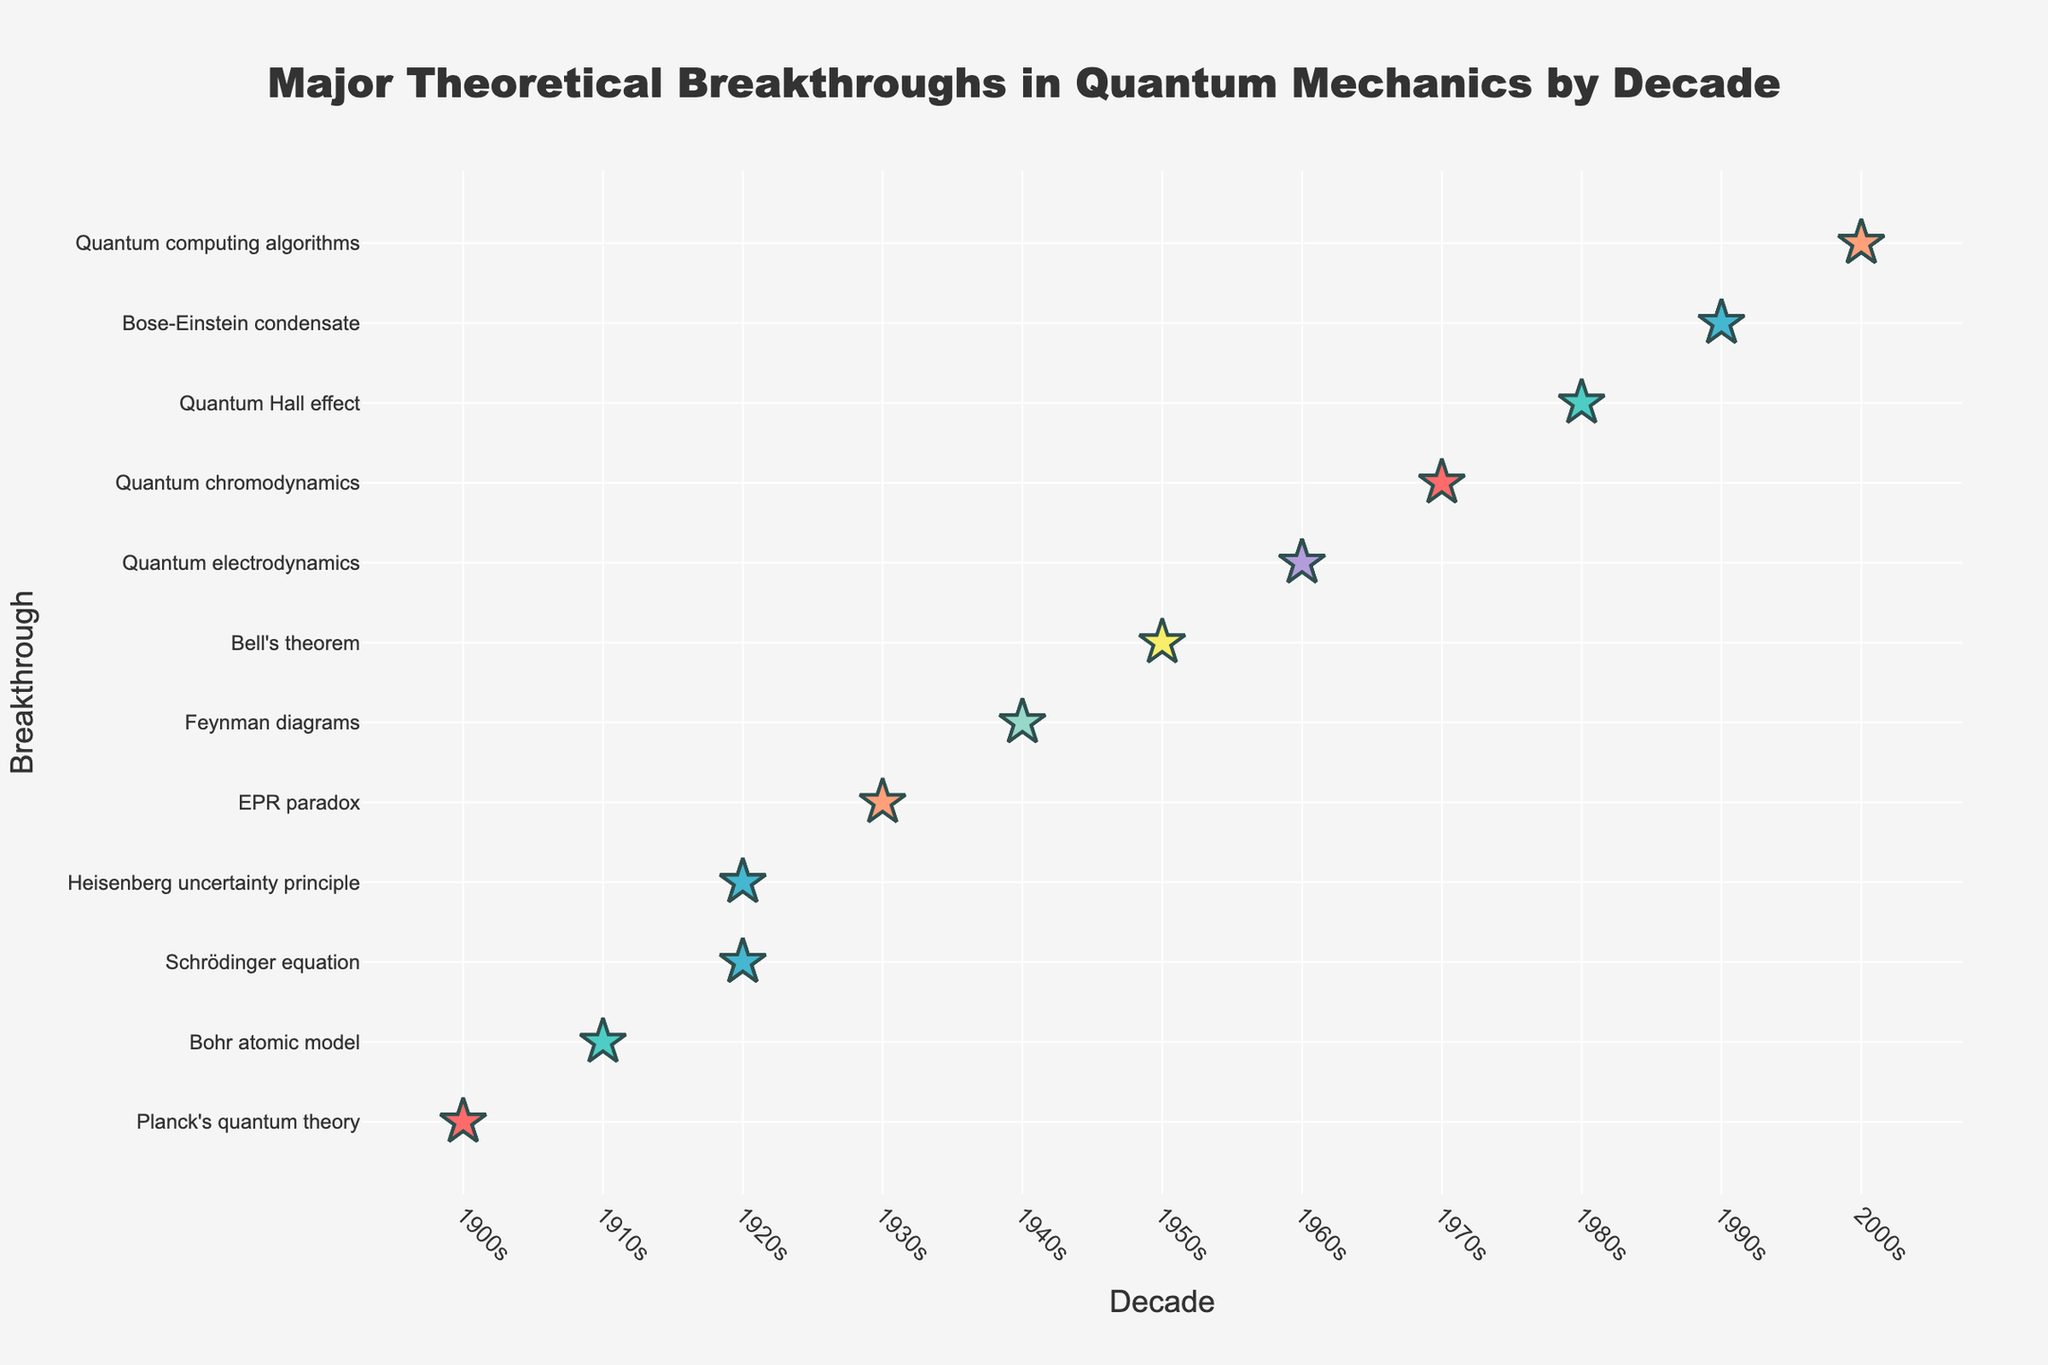What's the title of the figure? The title is prominently displayed at the top of the figure, usually in a larger and bolder font than the rest of the text. It reads, 'Major Theoretical Breakthroughs in Quantum Mechanics by Decade'.
Answer: Major Theoretical Breakthroughs in Quantum Mechanics by Decade How many breakthroughs are represented for the 1920s? By observing the figure, identify the number of marker symbols (stars) aligned with the 1920s on the x-axis. There are two breakthroughs shown: Schrödinger equation and Heisenberg uncertainty principle. Count the markers representing each breakthrough and sum them.
Answer: 7 Which breakthrough has the most markers in the 2000s? Locate the markers in the 2000s section of the plot. Identify and count the specific markers associated with each breakthrough in that decade to determine which has the highest number. 'Quantum computing algorithms' has the most with 4 markers.
Answer: Quantum computing algorithms How does the number of breakthroughs in the 1940s compare to those in the 1970s? Locate the markers for both the 1940s and the 1970s on the plot. Count the number of markers for each decade and then compare them. There are 3 markers for the 1940s (Feynman diagrams) and 2 markers for the 1970s (Quantum chromodynamics).
Answer: The 1940s have more breakthroughs What's the average number of breakthroughs per decade shown in the figure? Calculate the total number of markers representing all breakthroughs across each decade. Then, divide this total by the number of decades represented. Summing up the markers: 3 (1900s) + 2 (1910s) + 7 (1920s) + 2 (1930s) + 3 (1940s) + 2 (1950s) + 3 (1960s) + 2 (1970s) + 2 (1980s) + 3 (1990s) + 4 (2000s) = 33 markers over 11 decades. The average number of breakthroughs per decade is 33 / 11 = 3.
Answer: 3 Which decade has the least number of represented breakthroughs? Scan each decade on the x-axis and count the number of marker symbols in each. The 1910s, 1930s, 1950s, 1970s, and 1980s each have 2 markers.
Answer: 1910s, 1930s, 1950s, 1970s, 1980s What is the total number of breakthroughs represented for the 1920s and 2000s combined? Add the number of markers for the 1920s and the 2000s. For the 1920s, there are 7 markers (4 for Schrödinger equation, 3 for Heisenberg uncertainty principle) and for the 2000s, there are 4 markers (Quantum computing algorithms). Sum them up: 7 + 4 = 11.
Answer: 11 